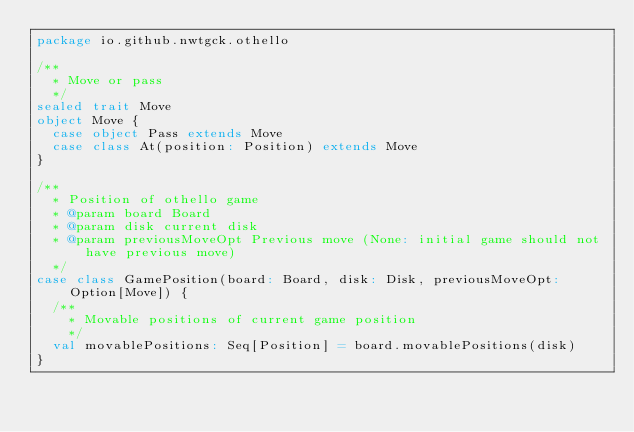<code> <loc_0><loc_0><loc_500><loc_500><_Scala_>package io.github.nwtgck.othello

/**
  * Move or pass
  */
sealed trait Move
object Move {
  case object Pass extends Move
  case class At(position: Position) extends Move
}

/**
  * Position of othello game
  * @param board Board
  * @param disk current disk
  * @param previousMoveOpt Previous move (None: initial game should not have previous move)
  */
case class GamePosition(board: Board, disk: Disk, previousMoveOpt: Option[Move]) {
  /**
    * Movable positions of current game position
    */
  val movablePositions: Seq[Position] = board.movablePositions(disk)
}
</code> 